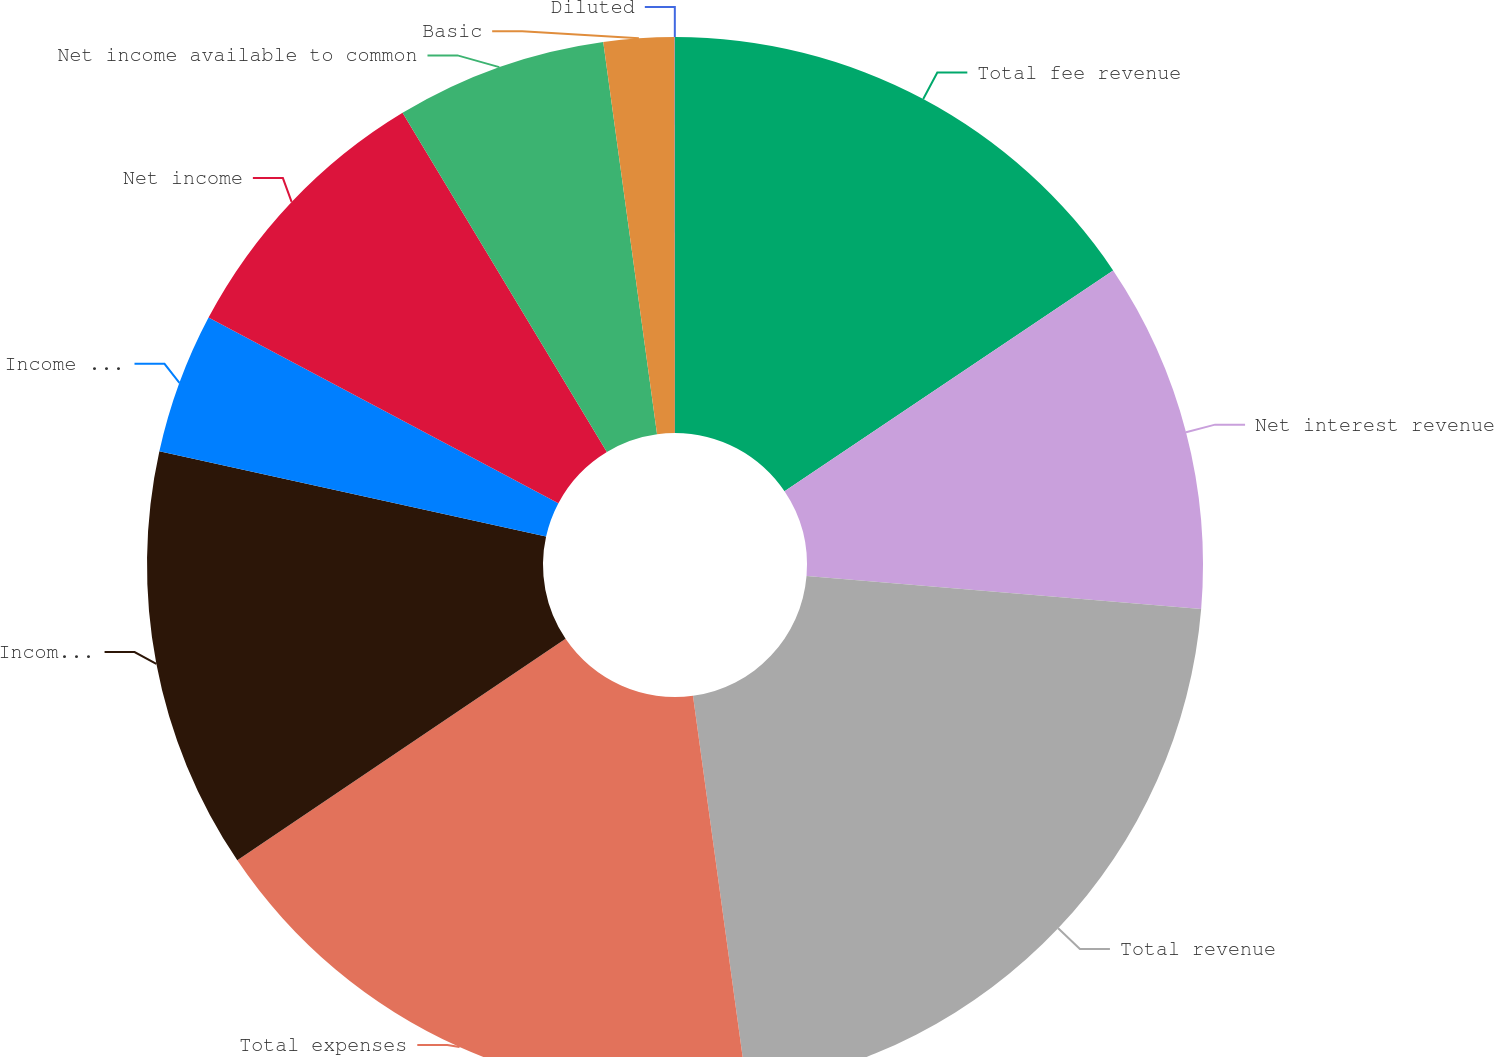<chart> <loc_0><loc_0><loc_500><loc_500><pie_chart><fcel>Total fee revenue<fcel>Net interest revenue<fcel>Total revenue<fcel>Total expenses<fcel>Income before income tax<fcel>Income tax expense<fcel>Net income<fcel>Net income available to common<fcel>Basic<fcel>Diluted<nl><fcel>15.58%<fcel>10.75%<fcel>21.5%<fcel>17.73%<fcel>12.9%<fcel>4.31%<fcel>8.61%<fcel>6.46%<fcel>2.16%<fcel>0.01%<nl></chart> 